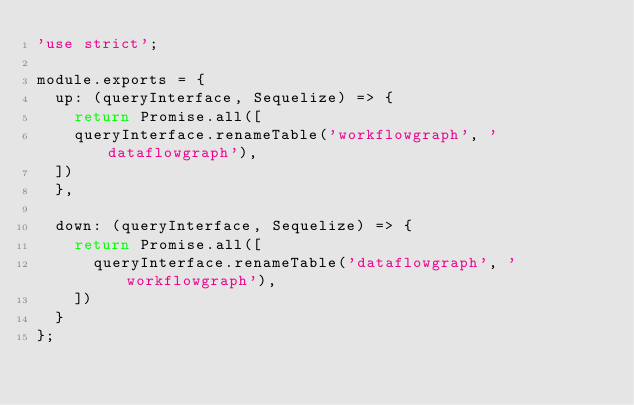<code> <loc_0><loc_0><loc_500><loc_500><_JavaScript_>'use strict';

module.exports = {
  up: (queryInterface, Sequelize) => {
    return Promise.all([
    queryInterface.renameTable('workflowgraph', 'dataflowgraph'),
  ])
  },

  down: (queryInterface, Sequelize) => {
    return Promise.all([
      queryInterface.renameTable('dataflowgraph', 'workflowgraph'),
    ])
  }
};
</code> 